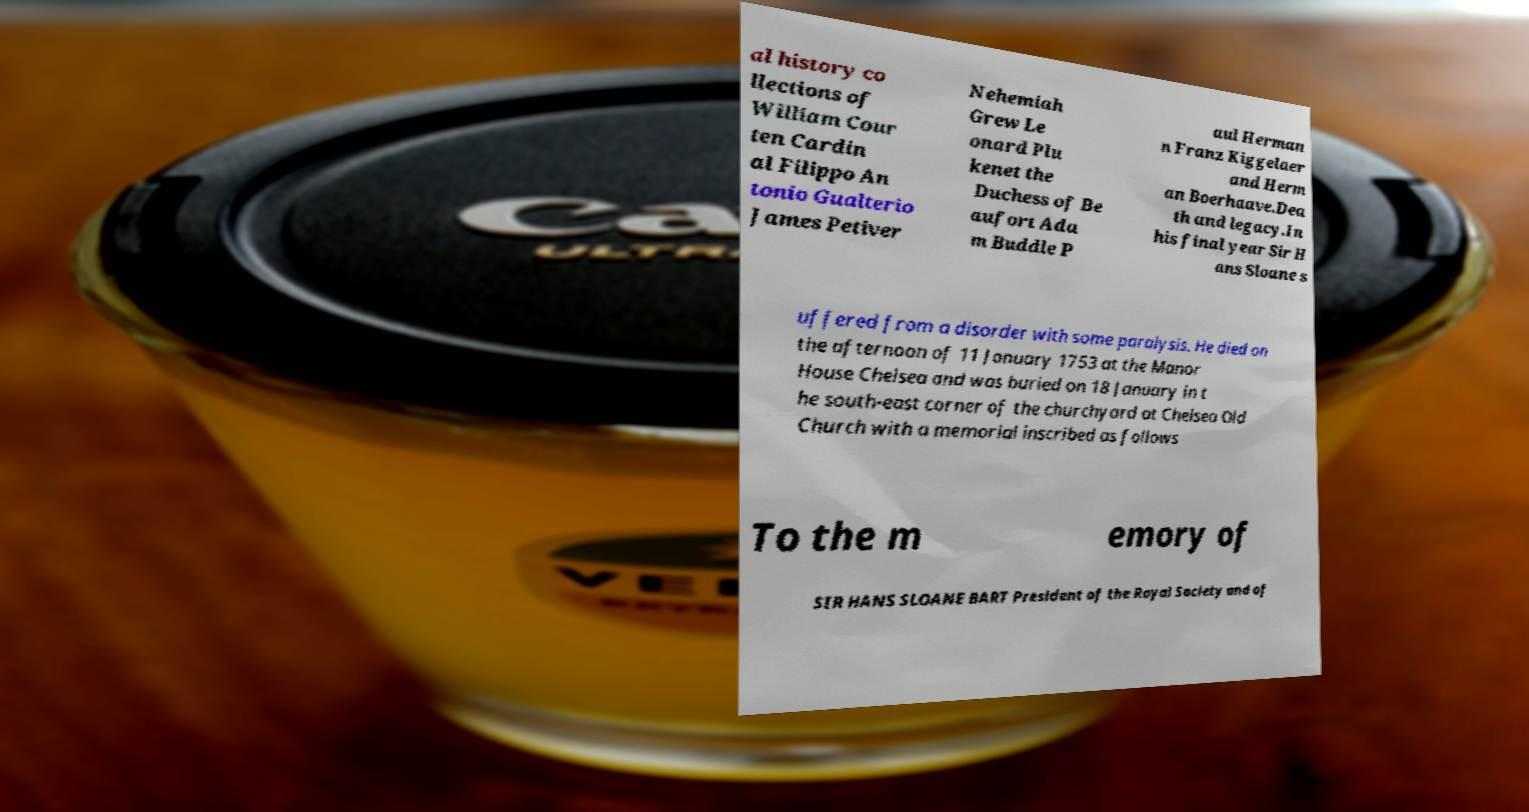There's text embedded in this image that I need extracted. Can you transcribe it verbatim? al history co llections of William Cour ten Cardin al Filippo An tonio Gualterio James Petiver Nehemiah Grew Le onard Plu kenet the Duchess of Be aufort Ada m Buddle P aul Herman n Franz Kiggelaer and Herm an Boerhaave.Dea th and legacy.In his final year Sir H ans Sloane s uffered from a disorder with some paralysis. He died on the afternoon of 11 January 1753 at the Manor House Chelsea and was buried on 18 January in t he south-east corner of the churchyard at Chelsea Old Church with a memorial inscribed as follows To the m emory of SIR HANS SLOANE BART President of the Royal Society and of 